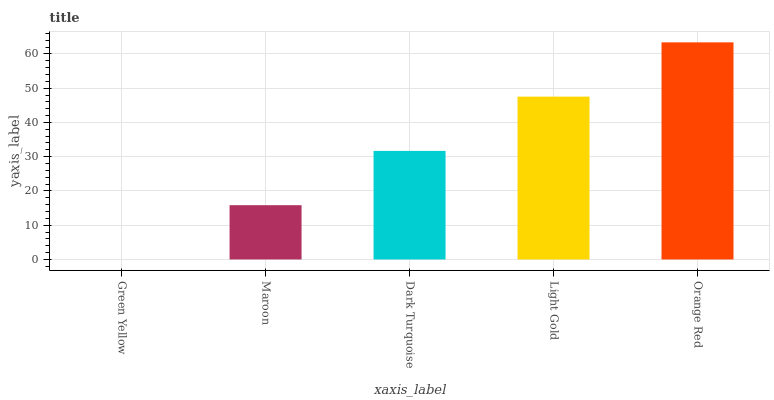Is Green Yellow the minimum?
Answer yes or no. Yes. Is Orange Red the maximum?
Answer yes or no. Yes. Is Maroon the minimum?
Answer yes or no. No. Is Maroon the maximum?
Answer yes or no. No. Is Maroon greater than Green Yellow?
Answer yes or no. Yes. Is Green Yellow less than Maroon?
Answer yes or no. Yes. Is Green Yellow greater than Maroon?
Answer yes or no. No. Is Maroon less than Green Yellow?
Answer yes or no. No. Is Dark Turquoise the high median?
Answer yes or no. Yes. Is Dark Turquoise the low median?
Answer yes or no. Yes. Is Light Gold the high median?
Answer yes or no. No. Is Light Gold the low median?
Answer yes or no. No. 